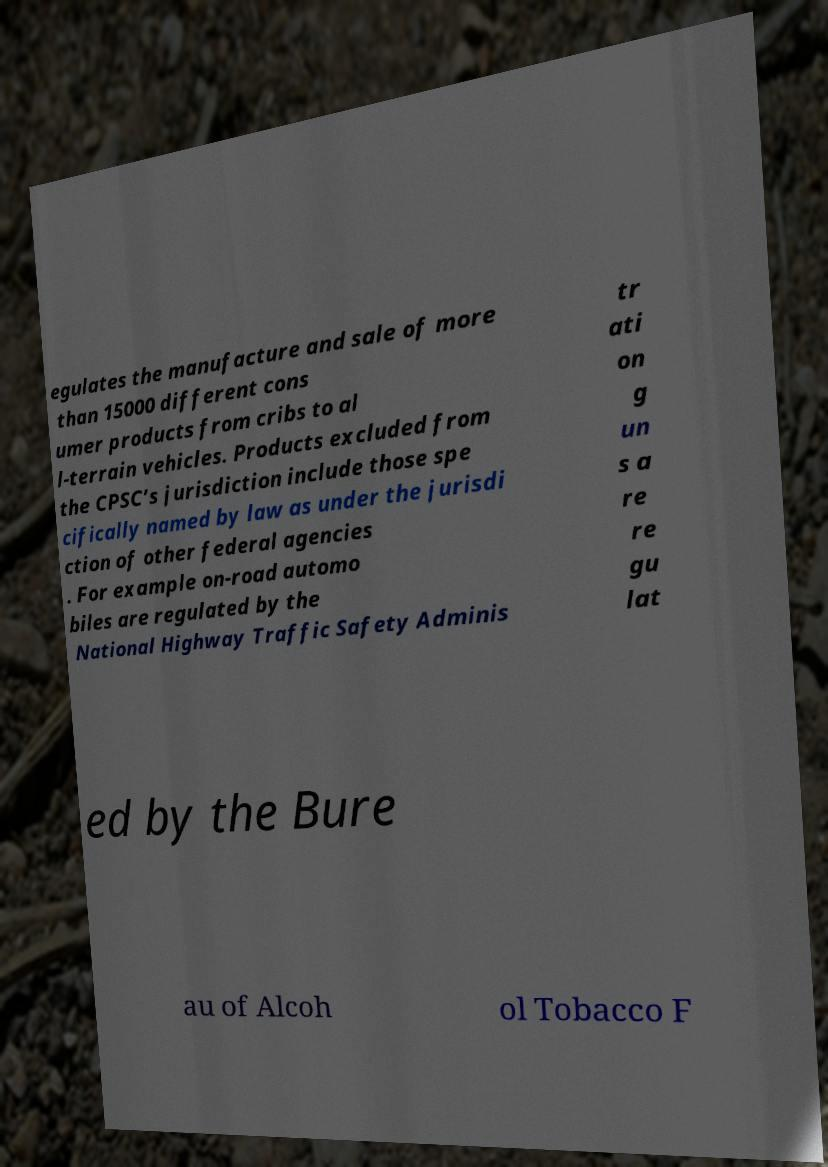Please identify and transcribe the text found in this image. egulates the manufacture and sale of more than 15000 different cons umer products from cribs to al l-terrain vehicles. Products excluded from the CPSC’s jurisdiction include those spe cifically named by law as under the jurisdi ction of other federal agencies . For example on-road automo biles are regulated by the National Highway Traffic Safety Adminis tr ati on g un s a re re gu lat ed by the Bure au of Alcoh ol Tobacco F 